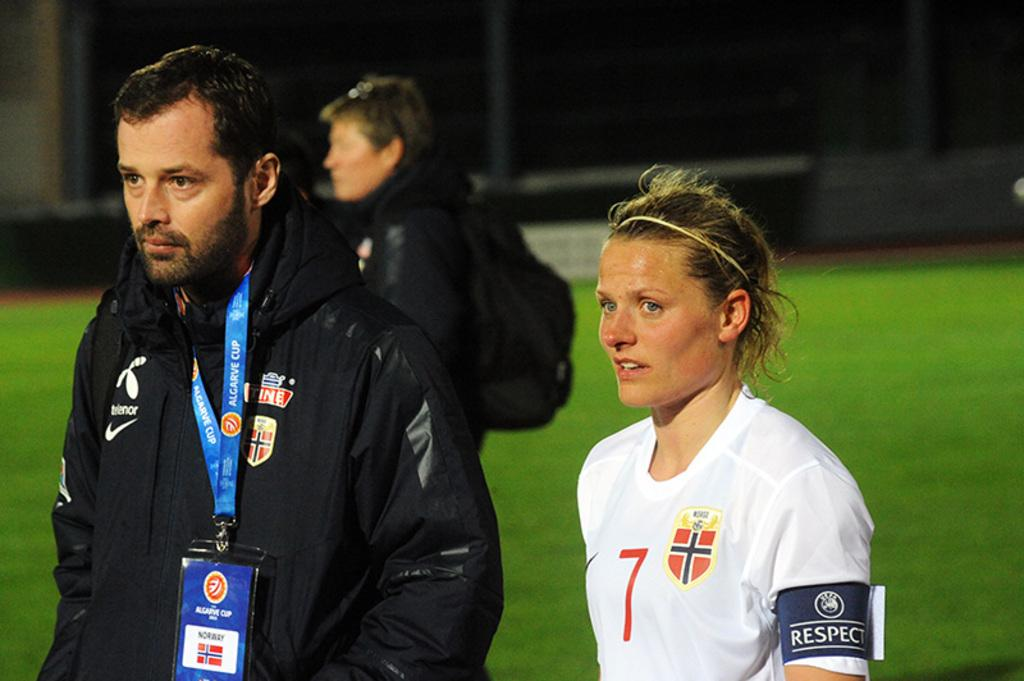<image>
Create a compact narrative representing the image presented. Two athletes are walking, one with the numeral 7 on her shirt. 